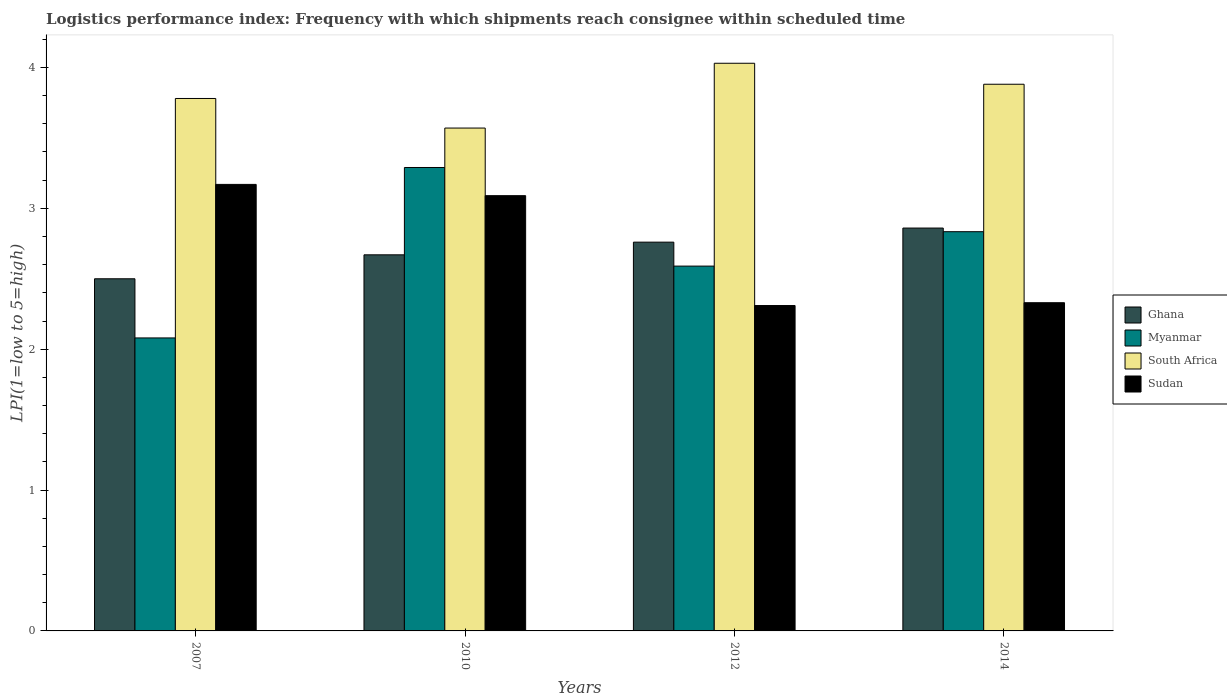How many groups of bars are there?
Your answer should be compact. 4. Are the number of bars per tick equal to the number of legend labels?
Offer a very short reply. Yes. Are the number of bars on each tick of the X-axis equal?
Keep it short and to the point. Yes. How many bars are there on the 2nd tick from the left?
Your answer should be very brief. 4. How many bars are there on the 2nd tick from the right?
Provide a succinct answer. 4. What is the label of the 4th group of bars from the left?
Your answer should be very brief. 2014. In how many cases, is the number of bars for a given year not equal to the number of legend labels?
Give a very brief answer. 0. What is the logistics performance index in Ghana in 2010?
Provide a short and direct response. 2.67. Across all years, what is the maximum logistics performance index in South Africa?
Your answer should be very brief. 4.03. Across all years, what is the minimum logistics performance index in Sudan?
Ensure brevity in your answer.  2.31. In which year was the logistics performance index in Sudan maximum?
Your response must be concise. 2007. What is the total logistics performance index in South Africa in the graph?
Make the answer very short. 15.26. What is the difference between the logistics performance index in South Africa in 2012 and that in 2014?
Provide a succinct answer. 0.15. What is the difference between the logistics performance index in South Africa in 2007 and the logistics performance index in Sudan in 2014?
Make the answer very short. 1.45. What is the average logistics performance index in South Africa per year?
Your answer should be very brief. 3.82. In the year 2014, what is the difference between the logistics performance index in South Africa and logistics performance index in Ghana?
Ensure brevity in your answer.  1.02. What is the ratio of the logistics performance index in Sudan in 2007 to that in 2012?
Offer a very short reply. 1.37. Is the logistics performance index in Myanmar in 2007 less than that in 2014?
Keep it short and to the point. Yes. Is the difference between the logistics performance index in South Africa in 2010 and 2012 greater than the difference between the logistics performance index in Ghana in 2010 and 2012?
Your answer should be very brief. No. What is the difference between the highest and the second highest logistics performance index in South Africa?
Give a very brief answer. 0.15. What is the difference between the highest and the lowest logistics performance index in Myanmar?
Provide a short and direct response. 1.21. Is the sum of the logistics performance index in Ghana in 2007 and 2010 greater than the maximum logistics performance index in Myanmar across all years?
Keep it short and to the point. Yes. What does the 3rd bar from the left in 2012 represents?
Provide a succinct answer. South Africa. What does the 1st bar from the right in 2010 represents?
Ensure brevity in your answer.  Sudan. Are all the bars in the graph horizontal?
Your response must be concise. No. How many years are there in the graph?
Offer a very short reply. 4. What is the difference between two consecutive major ticks on the Y-axis?
Keep it short and to the point. 1. Are the values on the major ticks of Y-axis written in scientific E-notation?
Offer a very short reply. No. Where does the legend appear in the graph?
Your answer should be very brief. Center right. What is the title of the graph?
Ensure brevity in your answer.  Logistics performance index: Frequency with which shipments reach consignee within scheduled time. Does "Ukraine" appear as one of the legend labels in the graph?
Your answer should be very brief. No. What is the label or title of the Y-axis?
Provide a short and direct response. LPI(1=low to 5=high). What is the LPI(1=low to 5=high) of Ghana in 2007?
Offer a terse response. 2.5. What is the LPI(1=low to 5=high) in Myanmar in 2007?
Your answer should be compact. 2.08. What is the LPI(1=low to 5=high) in South Africa in 2007?
Give a very brief answer. 3.78. What is the LPI(1=low to 5=high) in Sudan in 2007?
Give a very brief answer. 3.17. What is the LPI(1=low to 5=high) in Ghana in 2010?
Offer a very short reply. 2.67. What is the LPI(1=low to 5=high) in Myanmar in 2010?
Your response must be concise. 3.29. What is the LPI(1=low to 5=high) of South Africa in 2010?
Offer a terse response. 3.57. What is the LPI(1=low to 5=high) of Sudan in 2010?
Keep it short and to the point. 3.09. What is the LPI(1=low to 5=high) of Ghana in 2012?
Your answer should be very brief. 2.76. What is the LPI(1=low to 5=high) in Myanmar in 2012?
Your answer should be compact. 2.59. What is the LPI(1=low to 5=high) of South Africa in 2012?
Make the answer very short. 4.03. What is the LPI(1=low to 5=high) in Sudan in 2012?
Offer a very short reply. 2.31. What is the LPI(1=low to 5=high) of Ghana in 2014?
Your answer should be compact. 2.86. What is the LPI(1=low to 5=high) in Myanmar in 2014?
Provide a short and direct response. 2.83. What is the LPI(1=low to 5=high) of South Africa in 2014?
Make the answer very short. 3.88. What is the LPI(1=low to 5=high) of Sudan in 2014?
Give a very brief answer. 2.33. Across all years, what is the maximum LPI(1=low to 5=high) of Ghana?
Ensure brevity in your answer.  2.86. Across all years, what is the maximum LPI(1=low to 5=high) in Myanmar?
Your answer should be compact. 3.29. Across all years, what is the maximum LPI(1=low to 5=high) in South Africa?
Your response must be concise. 4.03. Across all years, what is the maximum LPI(1=low to 5=high) of Sudan?
Offer a terse response. 3.17. Across all years, what is the minimum LPI(1=low to 5=high) in Ghana?
Make the answer very short. 2.5. Across all years, what is the minimum LPI(1=low to 5=high) in Myanmar?
Your answer should be very brief. 2.08. Across all years, what is the minimum LPI(1=low to 5=high) in South Africa?
Provide a short and direct response. 3.57. Across all years, what is the minimum LPI(1=low to 5=high) in Sudan?
Make the answer very short. 2.31. What is the total LPI(1=low to 5=high) in Ghana in the graph?
Keep it short and to the point. 10.79. What is the total LPI(1=low to 5=high) in Myanmar in the graph?
Provide a short and direct response. 10.79. What is the total LPI(1=low to 5=high) of South Africa in the graph?
Offer a very short reply. 15.26. What is the total LPI(1=low to 5=high) in Sudan in the graph?
Offer a terse response. 10.9. What is the difference between the LPI(1=low to 5=high) in Ghana in 2007 and that in 2010?
Ensure brevity in your answer.  -0.17. What is the difference between the LPI(1=low to 5=high) in Myanmar in 2007 and that in 2010?
Your answer should be very brief. -1.21. What is the difference between the LPI(1=low to 5=high) of South Africa in 2007 and that in 2010?
Your answer should be very brief. 0.21. What is the difference between the LPI(1=low to 5=high) of Ghana in 2007 and that in 2012?
Make the answer very short. -0.26. What is the difference between the LPI(1=low to 5=high) of Myanmar in 2007 and that in 2012?
Your answer should be compact. -0.51. What is the difference between the LPI(1=low to 5=high) of Sudan in 2007 and that in 2012?
Offer a very short reply. 0.86. What is the difference between the LPI(1=low to 5=high) in Ghana in 2007 and that in 2014?
Offer a terse response. -0.36. What is the difference between the LPI(1=low to 5=high) of Myanmar in 2007 and that in 2014?
Provide a short and direct response. -0.75. What is the difference between the LPI(1=low to 5=high) in South Africa in 2007 and that in 2014?
Give a very brief answer. -0.1. What is the difference between the LPI(1=low to 5=high) in Sudan in 2007 and that in 2014?
Provide a short and direct response. 0.84. What is the difference between the LPI(1=low to 5=high) in Ghana in 2010 and that in 2012?
Ensure brevity in your answer.  -0.09. What is the difference between the LPI(1=low to 5=high) of South Africa in 2010 and that in 2012?
Your answer should be compact. -0.46. What is the difference between the LPI(1=low to 5=high) in Sudan in 2010 and that in 2012?
Make the answer very short. 0.78. What is the difference between the LPI(1=low to 5=high) in Ghana in 2010 and that in 2014?
Keep it short and to the point. -0.19. What is the difference between the LPI(1=low to 5=high) in Myanmar in 2010 and that in 2014?
Provide a succinct answer. 0.46. What is the difference between the LPI(1=low to 5=high) of South Africa in 2010 and that in 2014?
Your answer should be very brief. -0.31. What is the difference between the LPI(1=low to 5=high) of Sudan in 2010 and that in 2014?
Provide a short and direct response. 0.76. What is the difference between the LPI(1=low to 5=high) of Ghana in 2012 and that in 2014?
Offer a terse response. -0.1. What is the difference between the LPI(1=low to 5=high) of Myanmar in 2012 and that in 2014?
Ensure brevity in your answer.  -0.24. What is the difference between the LPI(1=low to 5=high) in South Africa in 2012 and that in 2014?
Provide a short and direct response. 0.15. What is the difference between the LPI(1=low to 5=high) of Sudan in 2012 and that in 2014?
Your response must be concise. -0.02. What is the difference between the LPI(1=low to 5=high) in Ghana in 2007 and the LPI(1=low to 5=high) in Myanmar in 2010?
Your answer should be very brief. -0.79. What is the difference between the LPI(1=low to 5=high) of Ghana in 2007 and the LPI(1=low to 5=high) of South Africa in 2010?
Provide a short and direct response. -1.07. What is the difference between the LPI(1=low to 5=high) of Ghana in 2007 and the LPI(1=low to 5=high) of Sudan in 2010?
Your answer should be very brief. -0.59. What is the difference between the LPI(1=low to 5=high) of Myanmar in 2007 and the LPI(1=low to 5=high) of South Africa in 2010?
Offer a terse response. -1.49. What is the difference between the LPI(1=low to 5=high) in Myanmar in 2007 and the LPI(1=low to 5=high) in Sudan in 2010?
Provide a short and direct response. -1.01. What is the difference between the LPI(1=low to 5=high) in South Africa in 2007 and the LPI(1=low to 5=high) in Sudan in 2010?
Make the answer very short. 0.69. What is the difference between the LPI(1=low to 5=high) in Ghana in 2007 and the LPI(1=low to 5=high) in Myanmar in 2012?
Make the answer very short. -0.09. What is the difference between the LPI(1=low to 5=high) in Ghana in 2007 and the LPI(1=low to 5=high) in South Africa in 2012?
Keep it short and to the point. -1.53. What is the difference between the LPI(1=low to 5=high) in Ghana in 2007 and the LPI(1=low to 5=high) in Sudan in 2012?
Your answer should be very brief. 0.19. What is the difference between the LPI(1=low to 5=high) of Myanmar in 2007 and the LPI(1=low to 5=high) of South Africa in 2012?
Offer a very short reply. -1.95. What is the difference between the LPI(1=low to 5=high) of Myanmar in 2007 and the LPI(1=low to 5=high) of Sudan in 2012?
Provide a succinct answer. -0.23. What is the difference between the LPI(1=low to 5=high) of South Africa in 2007 and the LPI(1=low to 5=high) of Sudan in 2012?
Make the answer very short. 1.47. What is the difference between the LPI(1=low to 5=high) in Ghana in 2007 and the LPI(1=low to 5=high) in Myanmar in 2014?
Give a very brief answer. -0.33. What is the difference between the LPI(1=low to 5=high) in Ghana in 2007 and the LPI(1=low to 5=high) in South Africa in 2014?
Your response must be concise. -1.38. What is the difference between the LPI(1=low to 5=high) in Ghana in 2007 and the LPI(1=low to 5=high) in Sudan in 2014?
Provide a short and direct response. 0.17. What is the difference between the LPI(1=low to 5=high) of Myanmar in 2007 and the LPI(1=low to 5=high) of South Africa in 2014?
Offer a terse response. -1.8. What is the difference between the LPI(1=low to 5=high) of Myanmar in 2007 and the LPI(1=low to 5=high) of Sudan in 2014?
Your answer should be very brief. -0.25. What is the difference between the LPI(1=low to 5=high) of South Africa in 2007 and the LPI(1=low to 5=high) of Sudan in 2014?
Ensure brevity in your answer.  1.45. What is the difference between the LPI(1=low to 5=high) in Ghana in 2010 and the LPI(1=low to 5=high) in Myanmar in 2012?
Offer a very short reply. 0.08. What is the difference between the LPI(1=low to 5=high) of Ghana in 2010 and the LPI(1=low to 5=high) of South Africa in 2012?
Keep it short and to the point. -1.36. What is the difference between the LPI(1=low to 5=high) of Ghana in 2010 and the LPI(1=low to 5=high) of Sudan in 2012?
Give a very brief answer. 0.36. What is the difference between the LPI(1=low to 5=high) in Myanmar in 2010 and the LPI(1=low to 5=high) in South Africa in 2012?
Ensure brevity in your answer.  -0.74. What is the difference between the LPI(1=low to 5=high) in South Africa in 2010 and the LPI(1=low to 5=high) in Sudan in 2012?
Your answer should be compact. 1.26. What is the difference between the LPI(1=low to 5=high) in Ghana in 2010 and the LPI(1=low to 5=high) in Myanmar in 2014?
Keep it short and to the point. -0.16. What is the difference between the LPI(1=low to 5=high) of Ghana in 2010 and the LPI(1=low to 5=high) of South Africa in 2014?
Provide a short and direct response. -1.21. What is the difference between the LPI(1=low to 5=high) of Ghana in 2010 and the LPI(1=low to 5=high) of Sudan in 2014?
Your answer should be compact. 0.34. What is the difference between the LPI(1=low to 5=high) in Myanmar in 2010 and the LPI(1=low to 5=high) in South Africa in 2014?
Ensure brevity in your answer.  -0.59. What is the difference between the LPI(1=low to 5=high) of Myanmar in 2010 and the LPI(1=low to 5=high) of Sudan in 2014?
Keep it short and to the point. 0.96. What is the difference between the LPI(1=low to 5=high) of South Africa in 2010 and the LPI(1=low to 5=high) of Sudan in 2014?
Your answer should be very brief. 1.24. What is the difference between the LPI(1=low to 5=high) of Ghana in 2012 and the LPI(1=low to 5=high) of Myanmar in 2014?
Provide a short and direct response. -0.07. What is the difference between the LPI(1=low to 5=high) in Ghana in 2012 and the LPI(1=low to 5=high) in South Africa in 2014?
Give a very brief answer. -1.12. What is the difference between the LPI(1=low to 5=high) in Ghana in 2012 and the LPI(1=low to 5=high) in Sudan in 2014?
Offer a very short reply. 0.43. What is the difference between the LPI(1=low to 5=high) in Myanmar in 2012 and the LPI(1=low to 5=high) in South Africa in 2014?
Offer a very short reply. -1.29. What is the difference between the LPI(1=low to 5=high) of Myanmar in 2012 and the LPI(1=low to 5=high) of Sudan in 2014?
Your response must be concise. 0.26. What is the difference between the LPI(1=low to 5=high) in South Africa in 2012 and the LPI(1=low to 5=high) in Sudan in 2014?
Make the answer very short. 1.7. What is the average LPI(1=low to 5=high) in Ghana per year?
Provide a succinct answer. 2.7. What is the average LPI(1=low to 5=high) of Myanmar per year?
Your response must be concise. 2.7. What is the average LPI(1=low to 5=high) in South Africa per year?
Give a very brief answer. 3.82. What is the average LPI(1=low to 5=high) in Sudan per year?
Make the answer very short. 2.73. In the year 2007, what is the difference between the LPI(1=low to 5=high) of Ghana and LPI(1=low to 5=high) of Myanmar?
Make the answer very short. 0.42. In the year 2007, what is the difference between the LPI(1=low to 5=high) of Ghana and LPI(1=low to 5=high) of South Africa?
Provide a short and direct response. -1.28. In the year 2007, what is the difference between the LPI(1=low to 5=high) in Ghana and LPI(1=low to 5=high) in Sudan?
Make the answer very short. -0.67. In the year 2007, what is the difference between the LPI(1=low to 5=high) of Myanmar and LPI(1=low to 5=high) of Sudan?
Keep it short and to the point. -1.09. In the year 2007, what is the difference between the LPI(1=low to 5=high) of South Africa and LPI(1=low to 5=high) of Sudan?
Your answer should be very brief. 0.61. In the year 2010, what is the difference between the LPI(1=low to 5=high) in Ghana and LPI(1=low to 5=high) in Myanmar?
Your answer should be very brief. -0.62. In the year 2010, what is the difference between the LPI(1=low to 5=high) in Ghana and LPI(1=low to 5=high) in South Africa?
Offer a very short reply. -0.9. In the year 2010, what is the difference between the LPI(1=low to 5=high) in Ghana and LPI(1=low to 5=high) in Sudan?
Provide a succinct answer. -0.42. In the year 2010, what is the difference between the LPI(1=low to 5=high) of Myanmar and LPI(1=low to 5=high) of South Africa?
Keep it short and to the point. -0.28. In the year 2010, what is the difference between the LPI(1=low to 5=high) in South Africa and LPI(1=low to 5=high) in Sudan?
Your answer should be compact. 0.48. In the year 2012, what is the difference between the LPI(1=low to 5=high) of Ghana and LPI(1=low to 5=high) of Myanmar?
Make the answer very short. 0.17. In the year 2012, what is the difference between the LPI(1=low to 5=high) in Ghana and LPI(1=low to 5=high) in South Africa?
Offer a terse response. -1.27. In the year 2012, what is the difference between the LPI(1=low to 5=high) of Ghana and LPI(1=low to 5=high) of Sudan?
Make the answer very short. 0.45. In the year 2012, what is the difference between the LPI(1=low to 5=high) of Myanmar and LPI(1=low to 5=high) of South Africa?
Provide a short and direct response. -1.44. In the year 2012, what is the difference between the LPI(1=low to 5=high) in Myanmar and LPI(1=low to 5=high) in Sudan?
Give a very brief answer. 0.28. In the year 2012, what is the difference between the LPI(1=low to 5=high) of South Africa and LPI(1=low to 5=high) of Sudan?
Make the answer very short. 1.72. In the year 2014, what is the difference between the LPI(1=low to 5=high) of Ghana and LPI(1=low to 5=high) of Myanmar?
Make the answer very short. 0.03. In the year 2014, what is the difference between the LPI(1=low to 5=high) of Ghana and LPI(1=low to 5=high) of South Africa?
Your answer should be very brief. -1.02. In the year 2014, what is the difference between the LPI(1=low to 5=high) of Ghana and LPI(1=low to 5=high) of Sudan?
Your answer should be very brief. 0.53. In the year 2014, what is the difference between the LPI(1=low to 5=high) of Myanmar and LPI(1=low to 5=high) of South Africa?
Provide a succinct answer. -1.05. In the year 2014, what is the difference between the LPI(1=low to 5=high) in Myanmar and LPI(1=low to 5=high) in Sudan?
Keep it short and to the point. 0.5. In the year 2014, what is the difference between the LPI(1=low to 5=high) in South Africa and LPI(1=low to 5=high) in Sudan?
Ensure brevity in your answer.  1.55. What is the ratio of the LPI(1=low to 5=high) in Ghana in 2007 to that in 2010?
Ensure brevity in your answer.  0.94. What is the ratio of the LPI(1=low to 5=high) in Myanmar in 2007 to that in 2010?
Give a very brief answer. 0.63. What is the ratio of the LPI(1=low to 5=high) in South Africa in 2007 to that in 2010?
Make the answer very short. 1.06. What is the ratio of the LPI(1=low to 5=high) of Sudan in 2007 to that in 2010?
Your answer should be very brief. 1.03. What is the ratio of the LPI(1=low to 5=high) in Ghana in 2007 to that in 2012?
Your answer should be compact. 0.91. What is the ratio of the LPI(1=low to 5=high) in Myanmar in 2007 to that in 2012?
Provide a succinct answer. 0.8. What is the ratio of the LPI(1=low to 5=high) in South Africa in 2007 to that in 2012?
Offer a terse response. 0.94. What is the ratio of the LPI(1=low to 5=high) of Sudan in 2007 to that in 2012?
Provide a succinct answer. 1.37. What is the ratio of the LPI(1=low to 5=high) of Ghana in 2007 to that in 2014?
Keep it short and to the point. 0.87. What is the ratio of the LPI(1=low to 5=high) of Myanmar in 2007 to that in 2014?
Offer a very short reply. 0.73. What is the ratio of the LPI(1=low to 5=high) of South Africa in 2007 to that in 2014?
Make the answer very short. 0.97. What is the ratio of the LPI(1=low to 5=high) in Sudan in 2007 to that in 2014?
Make the answer very short. 1.36. What is the ratio of the LPI(1=low to 5=high) of Ghana in 2010 to that in 2012?
Your response must be concise. 0.97. What is the ratio of the LPI(1=low to 5=high) in Myanmar in 2010 to that in 2012?
Offer a terse response. 1.27. What is the ratio of the LPI(1=low to 5=high) of South Africa in 2010 to that in 2012?
Your response must be concise. 0.89. What is the ratio of the LPI(1=low to 5=high) of Sudan in 2010 to that in 2012?
Your answer should be very brief. 1.34. What is the ratio of the LPI(1=low to 5=high) in Ghana in 2010 to that in 2014?
Make the answer very short. 0.93. What is the ratio of the LPI(1=low to 5=high) in Myanmar in 2010 to that in 2014?
Ensure brevity in your answer.  1.16. What is the ratio of the LPI(1=low to 5=high) of South Africa in 2010 to that in 2014?
Your response must be concise. 0.92. What is the ratio of the LPI(1=low to 5=high) of Sudan in 2010 to that in 2014?
Keep it short and to the point. 1.33. What is the ratio of the LPI(1=low to 5=high) of Ghana in 2012 to that in 2014?
Provide a short and direct response. 0.96. What is the ratio of the LPI(1=low to 5=high) in Myanmar in 2012 to that in 2014?
Keep it short and to the point. 0.91. What is the ratio of the LPI(1=low to 5=high) in South Africa in 2012 to that in 2014?
Ensure brevity in your answer.  1.04. What is the ratio of the LPI(1=low to 5=high) in Sudan in 2012 to that in 2014?
Ensure brevity in your answer.  0.99. What is the difference between the highest and the second highest LPI(1=low to 5=high) in Myanmar?
Your answer should be very brief. 0.46. What is the difference between the highest and the second highest LPI(1=low to 5=high) of South Africa?
Keep it short and to the point. 0.15. What is the difference between the highest and the second highest LPI(1=low to 5=high) of Sudan?
Your answer should be very brief. 0.08. What is the difference between the highest and the lowest LPI(1=low to 5=high) of Ghana?
Your response must be concise. 0.36. What is the difference between the highest and the lowest LPI(1=low to 5=high) of Myanmar?
Your response must be concise. 1.21. What is the difference between the highest and the lowest LPI(1=low to 5=high) of South Africa?
Offer a terse response. 0.46. What is the difference between the highest and the lowest LPI(1=low to 5=high) in Sudan?
Your answer should be very brief. 0.86. 